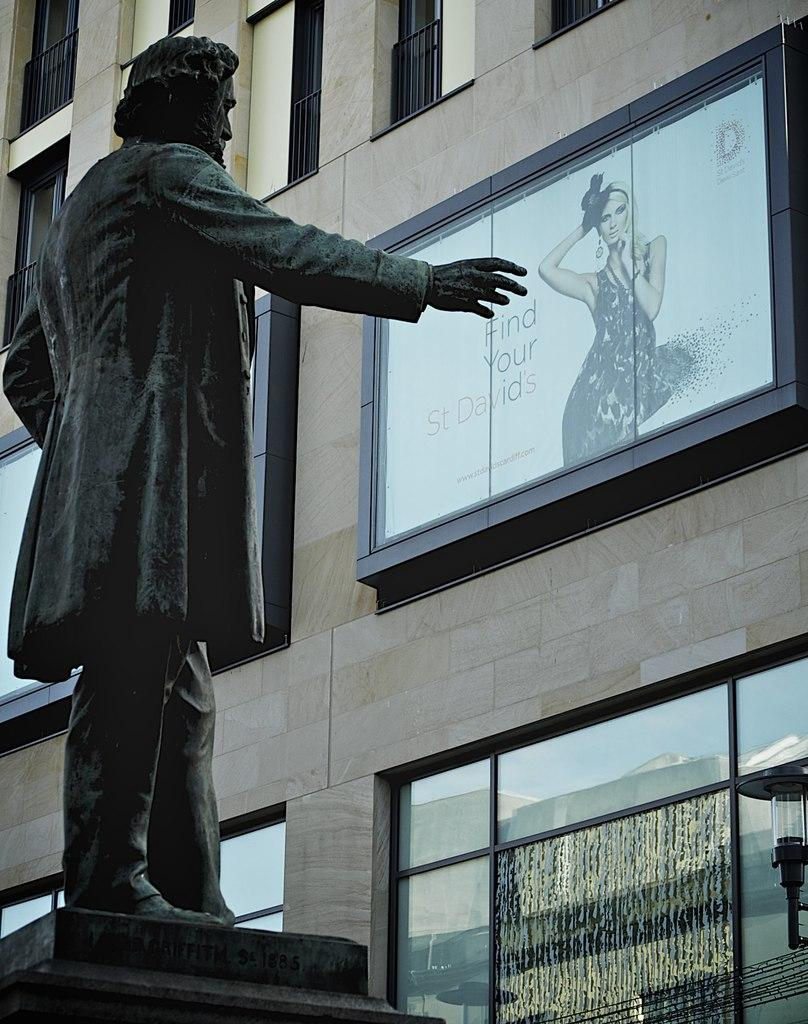What type of structure can be seen in the image? There is a building in the image. What is the purpose of the screen in the image? The purpose of the screen is not specified in the image. What is the source of illumination in the image? There is a light in the image. What objects are present in the image? There are objects in the image, but their specific nature is not mentioned. What can be seen on the glass in the image? There is a reflection on the glass in the image. What type of statue is present in the image? There is a statue of a man in the image. How is the statue positioned in the image? The statue is placed on a pedestal. What is the man's favorite hobby, as depicted in the statue? The statue does not depict the man's hobbies; it is a statue of a man standing on a pedestal. What is the temper of the statue in the image? The statue is an inanimate object and does not have a temper. 